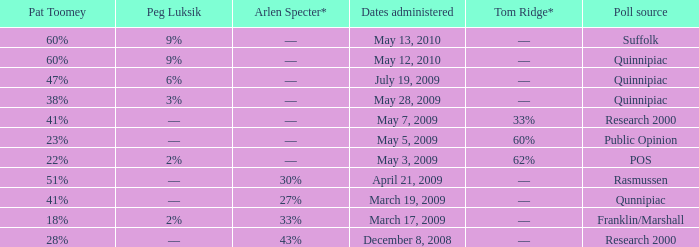Which Poll source has an Arlen Specter* of ––, and a Tom Ridge* of 60%? Public Opinion. 